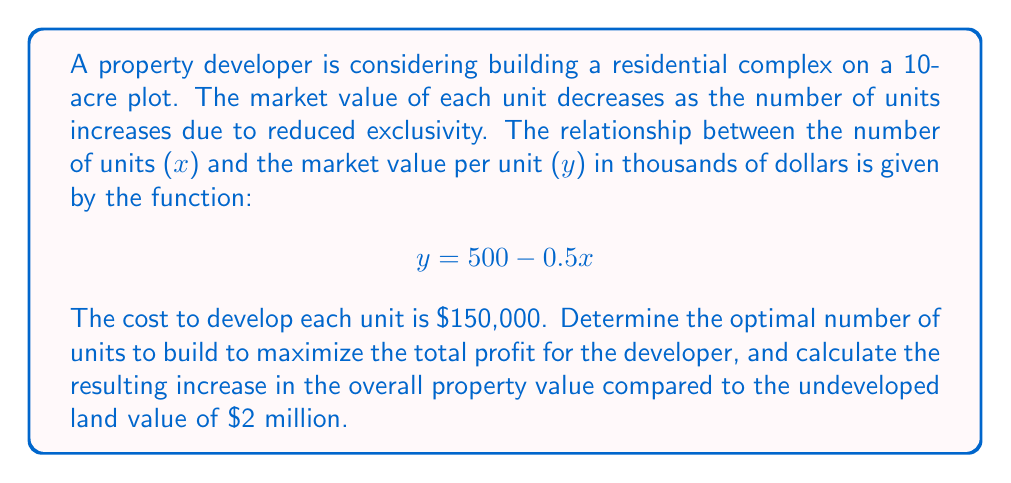Can you solve this math problem? 1) First, let's define the profit function. The total revenue is the number of units multiplied by the price per unit:

   Revenue = $x(500 - 0.5x)$ thousand
   
   = $(500x - 0.5x^2)$ thousand
   
   = $(500,000x - 500x^2)$ dollars

2) The total cost is the number of units multiplied by the cost per unit, plus the initial land value:

   Cost = $150,000x + 2,000,000$ dollars

3) The profit function is revenue minus cost:

   $$P(x) = (500,000x - 500x^2) - (150,000x + 2,000,000)$$
   $$P(x) = 350,000x - 500x^2 - 2,000,000$$

4) To find the maximum profit, we differentiate P(x) and set it to zero:

   $$\frac{dP}{dx} = 350,000 - 1000x = 0$$
   $$1000x = 350,000$$
   $$x = 350$$

5) The second derivative is negative (-1000), confirming this is a maximum.

6) Therefore, the optimal number of units to build is 350.

7) To calculate the increase in property value:
   - Value of developed property = Revenue = $500,000(350) - 500(350^2) = 87,500,000$
   - Increase in value = $87,500,000 - 2,000,000 = 85,500,000$
Answer: 350 units; $85,500,000 increase 